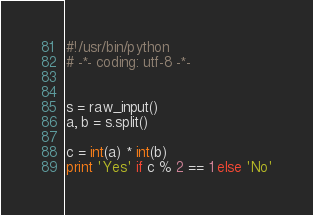<code> <loc_0><loc_0><loc_500><loc_500><_Python_>#!/usr/bin/python
# -*- coding: utf-8 -*-


s = raw_input()
a, b = s.split()

c = int(a) * int(b)
print 'Yes' if c % 2 == 1 else 'No'</code> 